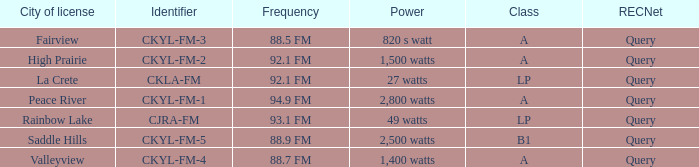What frequency is licensed in the city of fairview? 88.5 FM. 